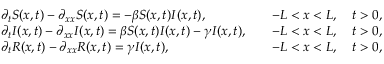Convert formula to latex. <formula><loc_0><loc_0><loc_500><loc_500>\begin{array} { r l r } & { \partial _ { t } S ( x , t ) - \partial _ { x x } S ( x , t ) = - \beta S ( x , t ) I ( x , t ) , } & { \quad - L < x < L , \quad t > 0 , } \\ & { \partial _ { t } I ( x , t ) - \partial _ { x x } I ( x , t ) = \beta S ( x , t ) I ( x , t ) - \gamma I ( x , t ) , } & { \quad - L < x < L , \quad t > 0 , } \\ & { \partial _ { t } R ( x , t ) - \partial _ { x x } R ( x , t ) = \gamma I ( x , t ) , } & { \quad - L < x < L , \quad t > 0 , } \end{array}</formula> 